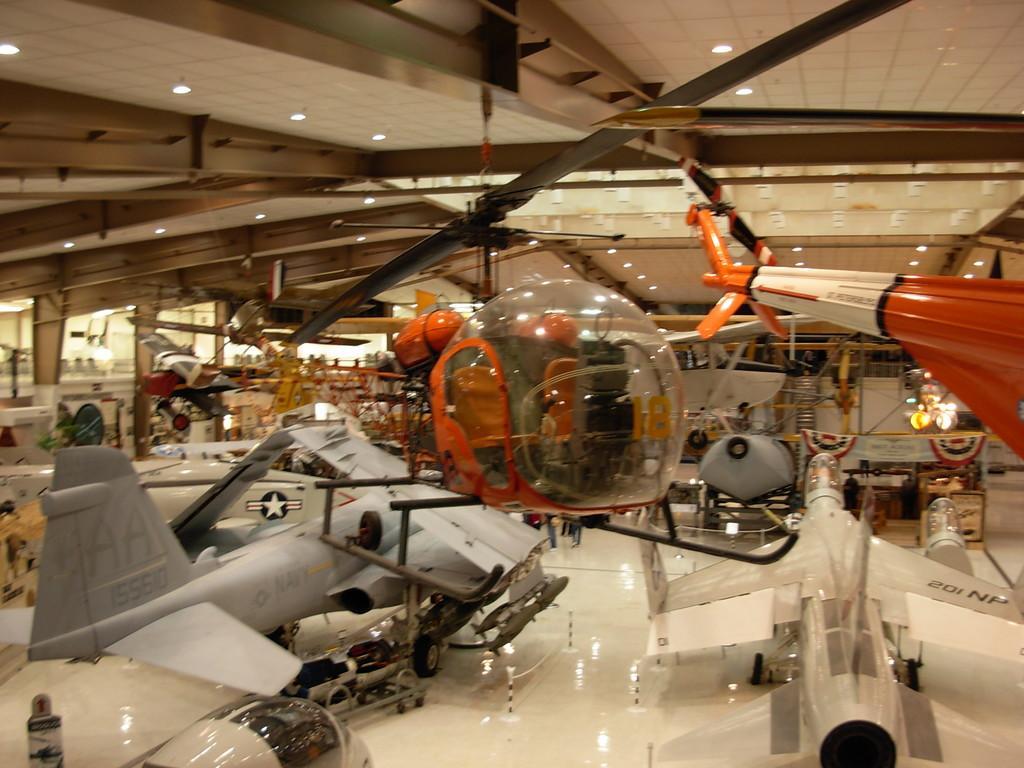Describe this image in one or two sentences. In this image we can see many aircrafts. There are many lights attached to a roof. 